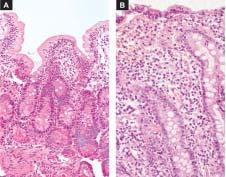what is there of the villi and crypt hyperplasia?
Answer the question using a single word or phrase. Near total flattening 